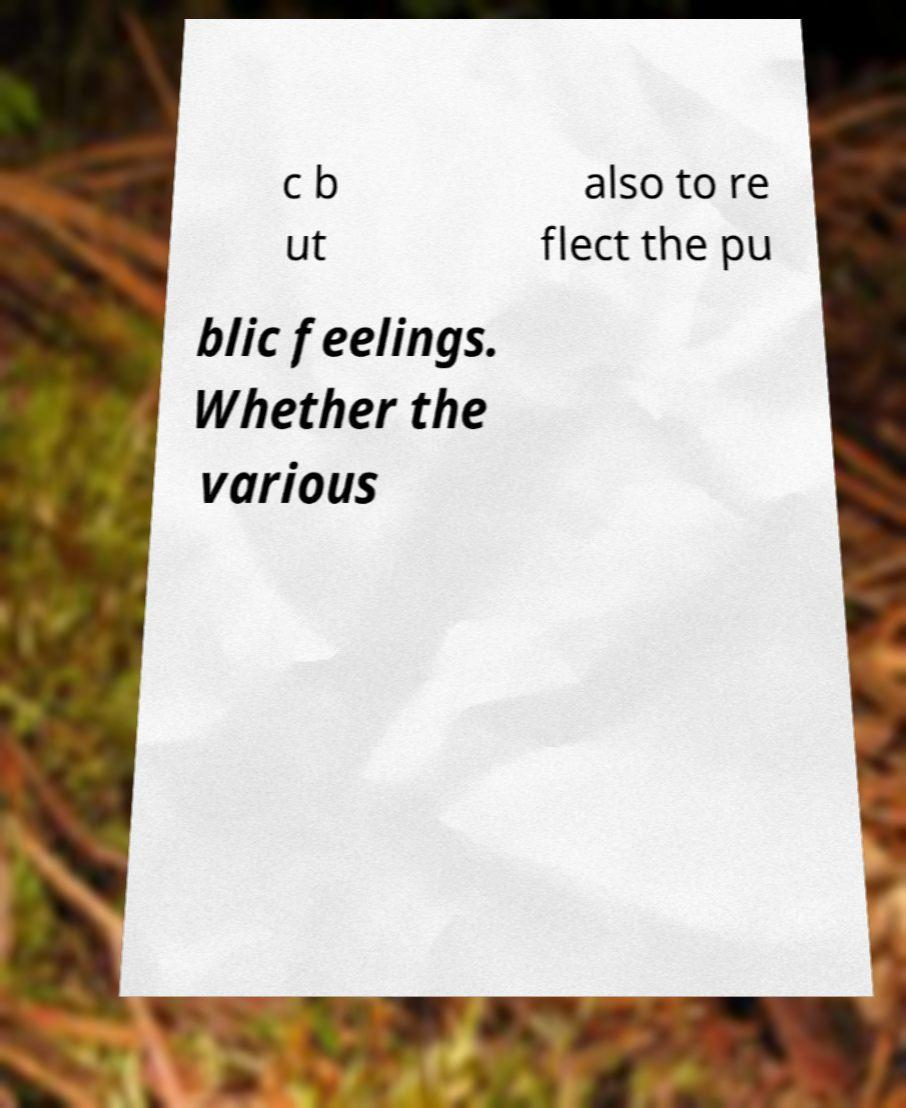Can you read and provide the text displayed in the image?This photo seems to have some interesting text. Can you extract and type it out for me? c b ut also to re flect the pu blic feelings. Whether the various 